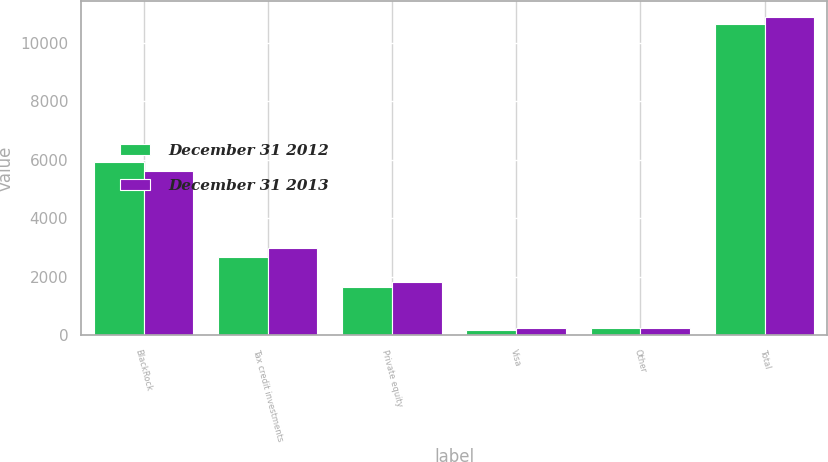<chart> <loc_0><loc_0><loc_500><loc_500><stacked_bar_chart><ecel><fcel>BlackRock<fcel>Tax credit investments<fcel>Private equity<fcel>Visa<fcel>Other<fcel>Total<nl><fcel>December 31 2012<fcel>5940<fcel>2676<fcel>1656<fcel>158<fcel>234<fcel>10664<nl><fcel>December 31 2013<fcel>5614<fcel>2965<fcel>1802<fcel>251<fcel>245<fcel>10877<nl></chart> 